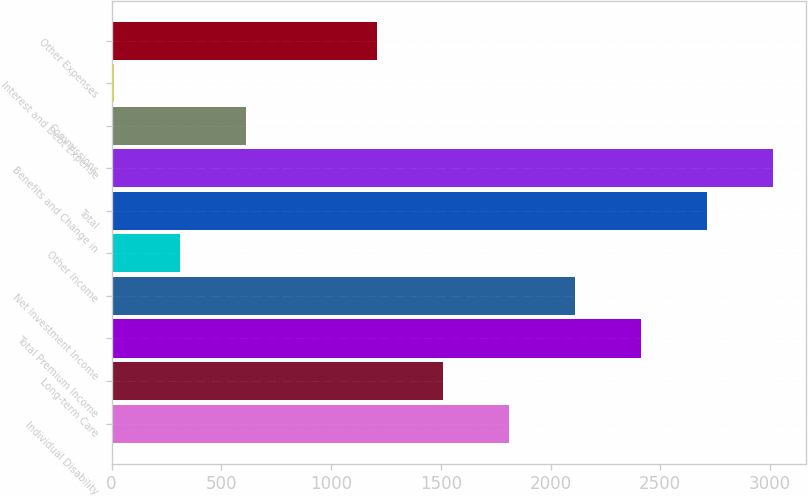Convert chart. <chart><loc_0><loc_0><loc_500><loc_500><bar_chart><fcel>Individual Disability<fcel>Long-term Care<fcel>Total Premium Income<fcel>Net Investment Income<fcel>Other Income<fcel>Total<fcel>Benefits and Change in<fcel>Commissions<fcel>Interest and Debt Expense<fcel>Other Expenses<nl><fcel>1811.88<fcel>1511.65<fcel>2412.34<fcel>2112.11<fcel>310.73<fcel>2712.57<fcel>3012.8<fcel>610.96<fcel>10.5<fcel>1211.42<nl></chart> 